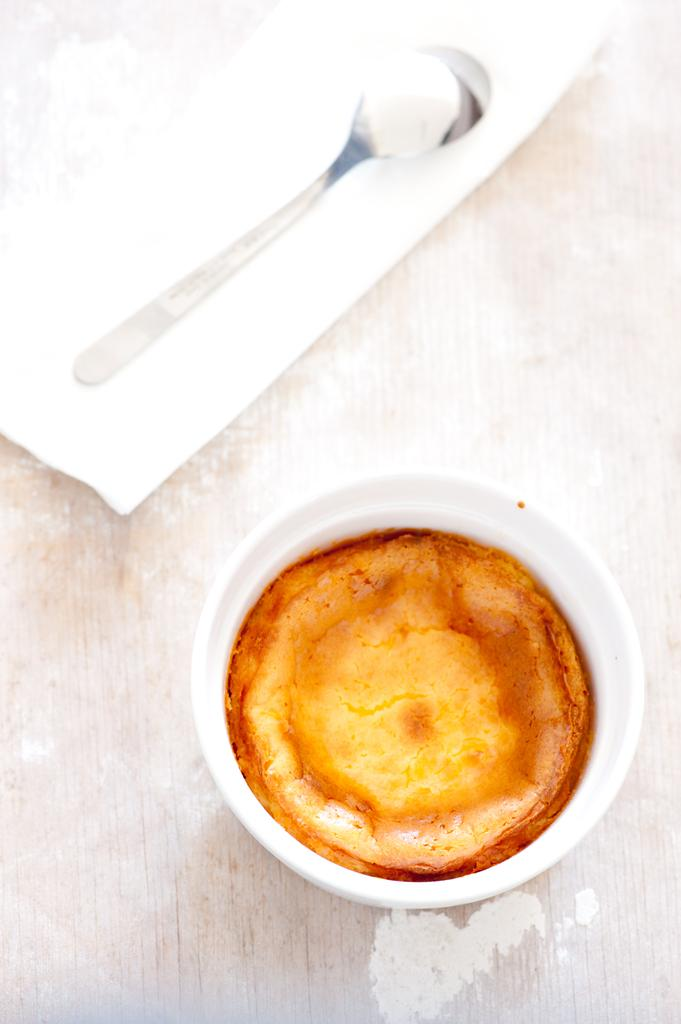What is in the cup that is visible in the image? There is a beverage in a cup in the image. What other items can be seen in the image besides the cup? There is a paper and a spoon visible in the image. Can you describe the setting of the image? The image is likely taken in a room. How many pieces of lumber are stacked in the corner of the room in the image? There is no lumber visible in the image, so it is not possible to determine how many pieces might be stacked in the corner. 